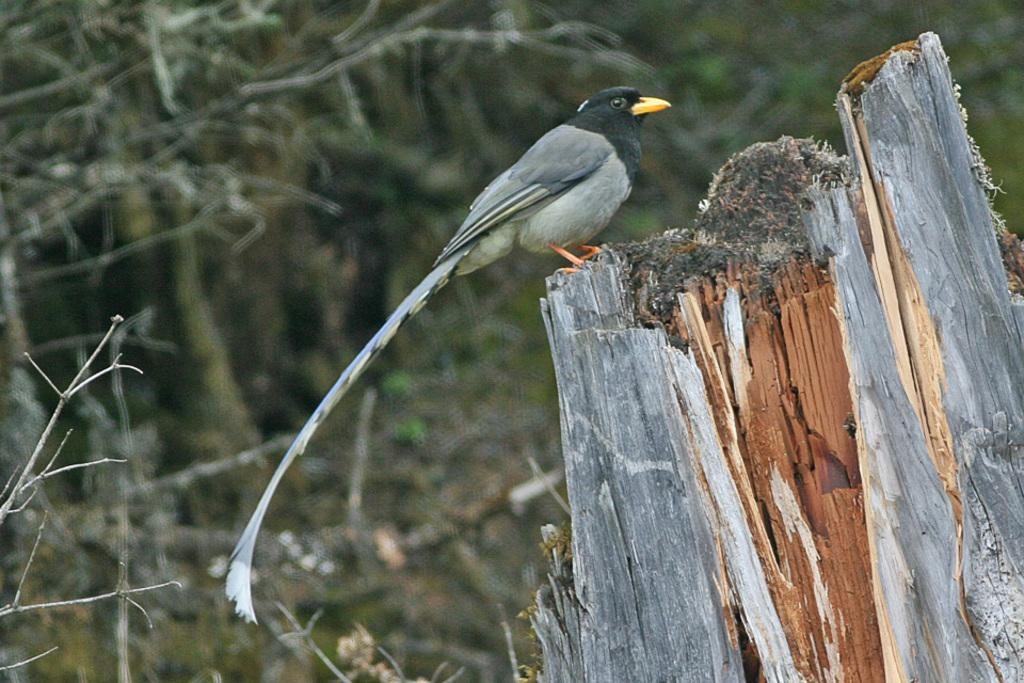What type of animal is present in the image? There is a bird in the image. Where is the bird located? The bird is on a wooden platform. Can you describe the background of the image? The background of the image is blurry. How many grapes are being used for the expansion of the pizzas in the image? There are no grapes or pizzas present in the image; it features a bird on a wooden platform with a blurry background. 